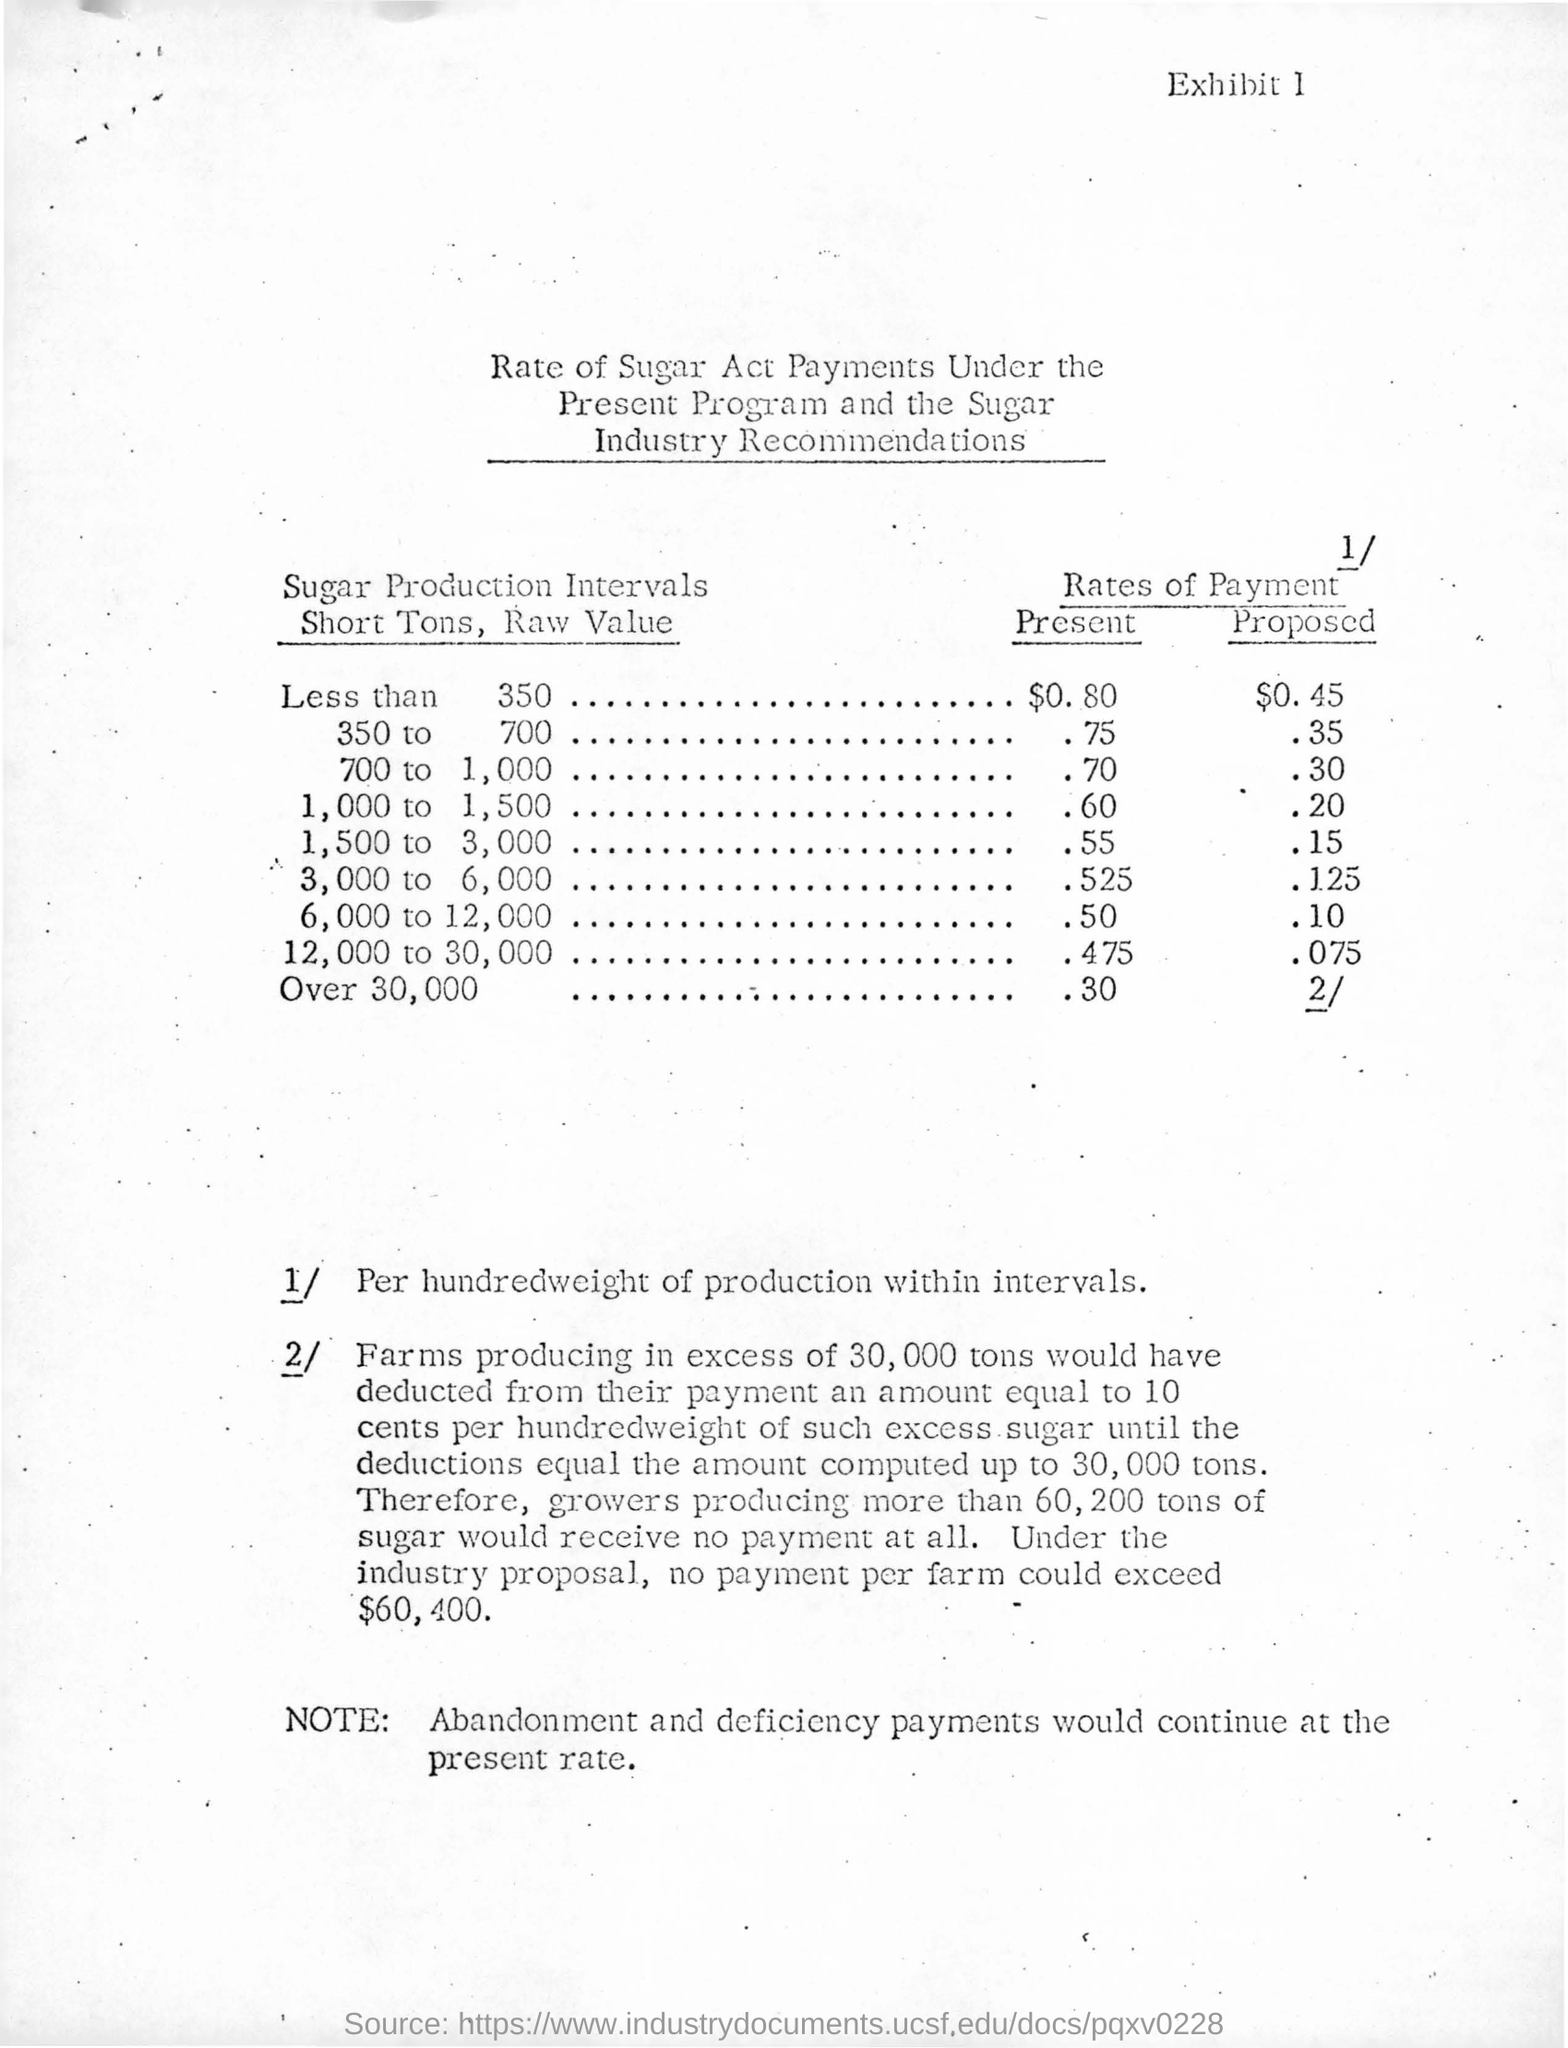Indicate a few pertinent items in this graphic. The exhibit number is 1. 